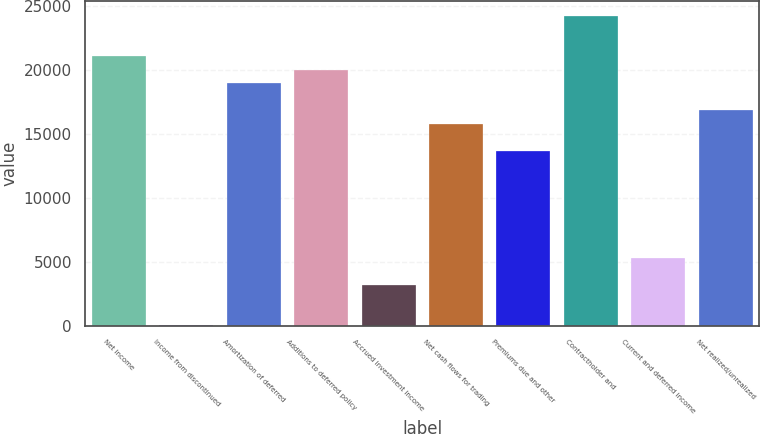Convert chart. <chart><loc_0><loc_0><loc_500><loc_500><bar_chart><fcel>Net income<fcel>Income from discontinued<fcel>Amortization of deferred<fcel>Additions to deferred policy<fcel>Accrued investment income<fcel>Net cash flows for trading<fcel>Premiums due and other<fcel>Contractholder and<fcel>Current and deferred income<fcel>Net realized/unrealized<nl><fcel>21020.4<fcel>20.2<fcel>18920.4<fcel>19970.4<fcel>3170.23<fcel>15770.4<fcel>13670.3<fcel>24170.4<fcel>5270.25<fcel>16820.4<nl></chart> 